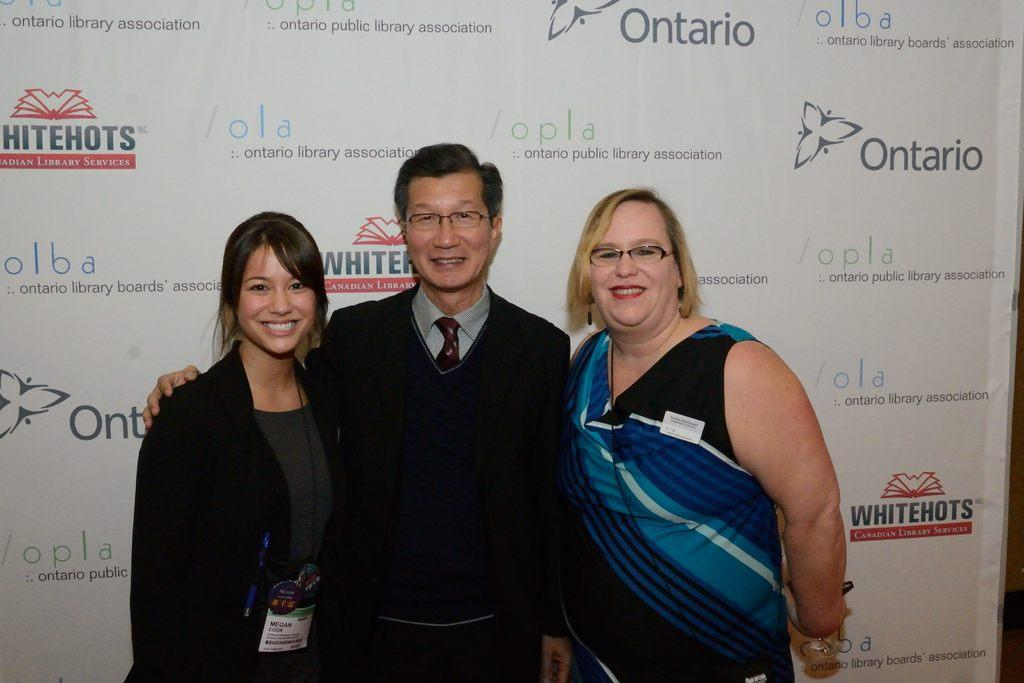<image>
Provide a brief description of the given image. Three people getting their photo taken next to a background that says Whitehots Ontario. 